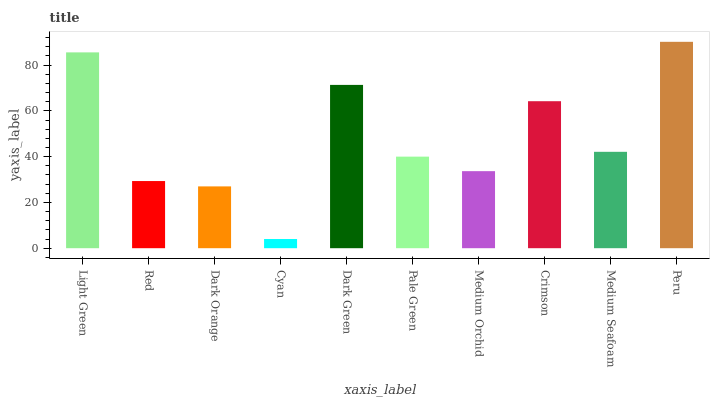Is Cyan the minimum?
Answer yes or no. Yes. Is Peru the maximum?
Answer yes or no. Yes. Is Red the minimum?
Answer yes or no. No. Is Red the maximum?
Answer yes or no. No. Is Light Green greater than Red?
Answer yes or no. Yes. Is Red less than Light Green?
Answer yes or no. Yes. Is Red greater than Light Green?
Answer yes or no. No. Is Light Green less than Red?
Answer yes or no. No. Is Medium Seafoam the high median?
Answer yes or no. Yes. Is Pale Green the low median?
Answer yes or no. Yes. Is Dark Orange the high median?
Answer yes or no. No. Is Medium Orchid the low median?
Answer yes or no. No. 